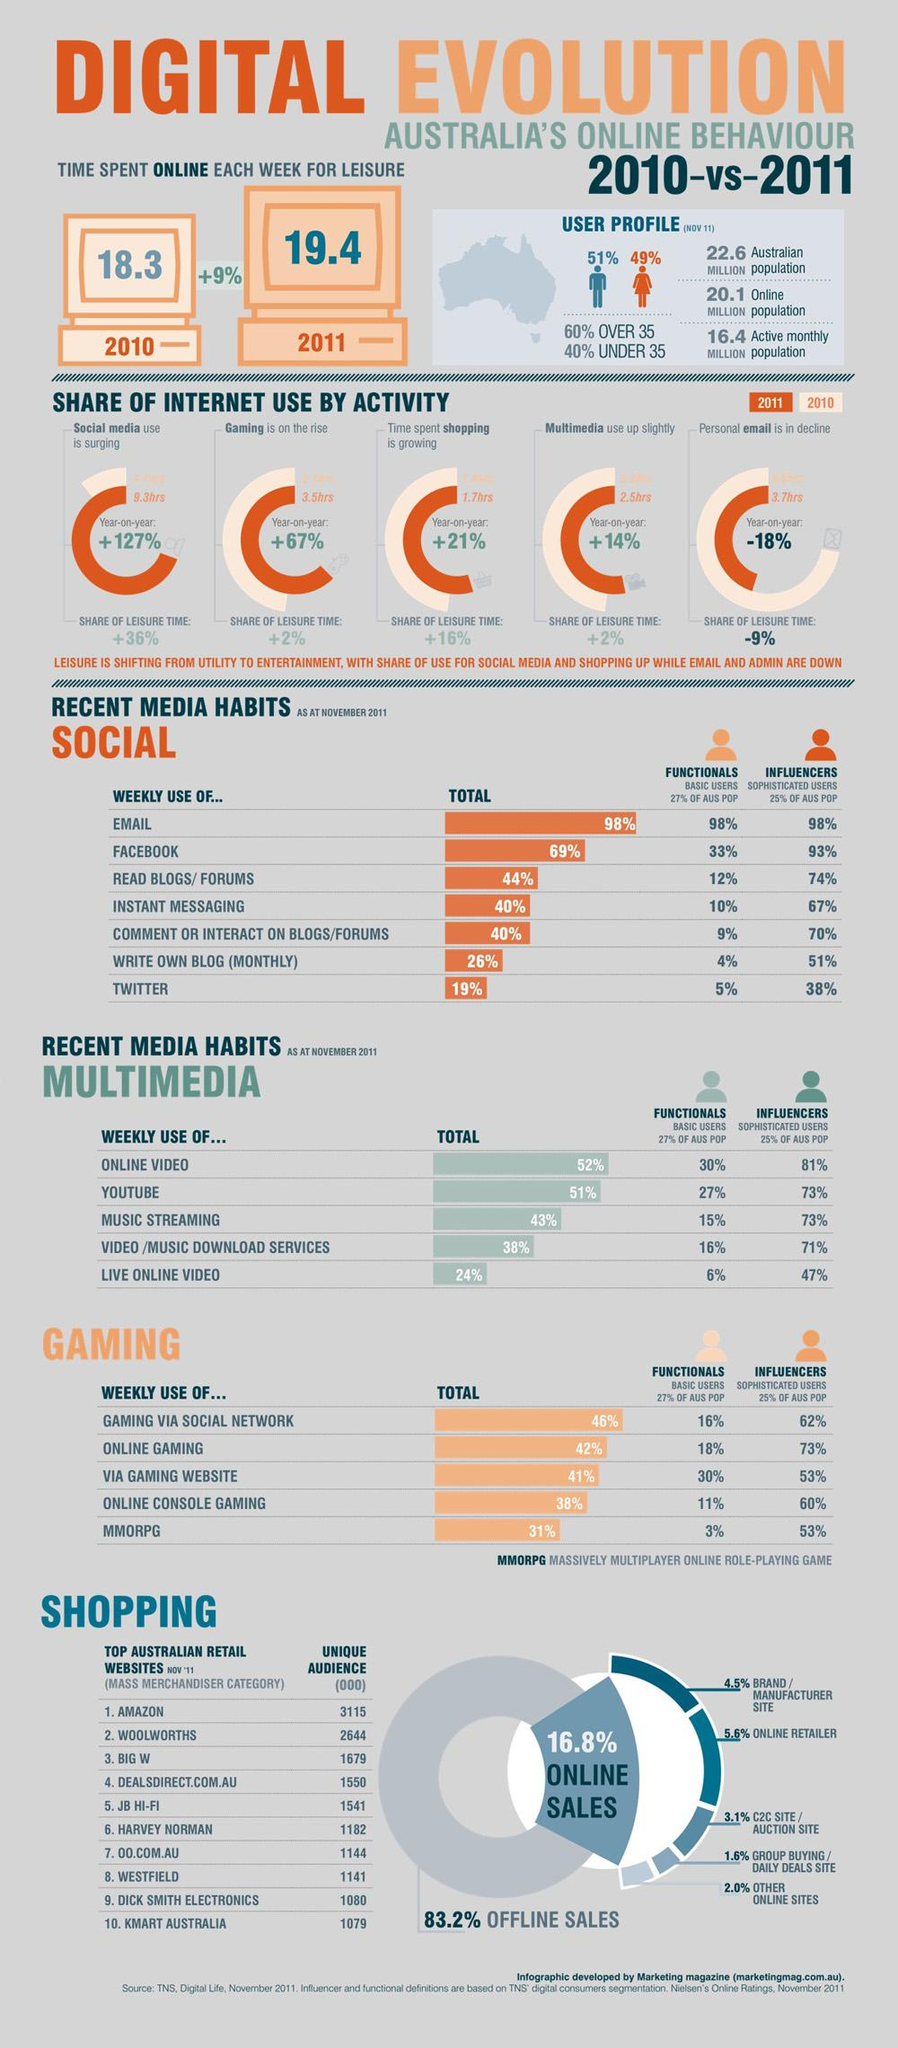Identify some key points in this picture. Facebook is the second most commonly used social media platform among Australians on a weekly basis. There are 471 fewer visitors to the second-ranked Australian shopping website compared to the top website. In 2011, the average Australian spent 1.7 hours engaging in online shopping. In Australia, a significant majority of sales, approximately 83.2%, are not made online. According to a survey on weekly gaming usage in Australia, the third most popular type of gaming among Australians is through gaming websites. 